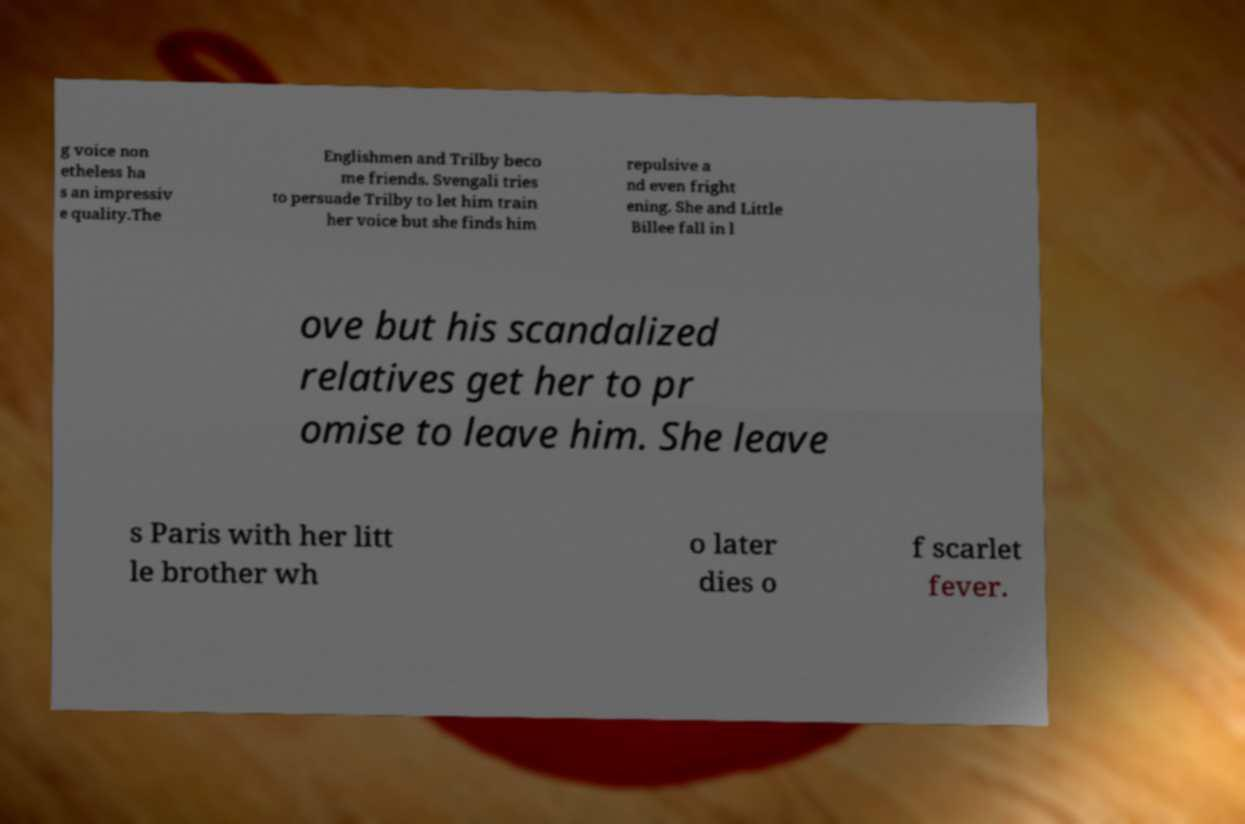Could you extract and type out the text from this image? g voice non etheless ha s an impressiv e quality.The Englishmen and Trilby beco me friends. Svengali tries to persuade Trilby to let him train her voice but she finds him repulsive a nd even fright ening. She and Little Billee fall in l ove but his scandalized relatives get her to pr omise to leave him. She leave s Paris with her litt le brother wh o later dies o f scarlet fever. 